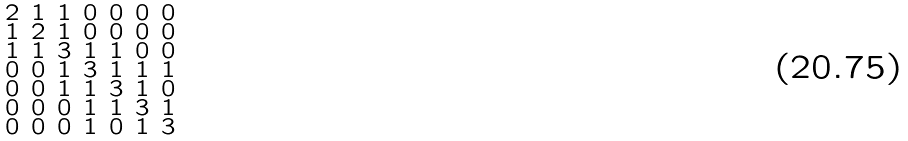Convert formula to latex. <formula><loc_0><loc_0><loc_500><loc_500>\begin{smallmatrix} 2 & 1 & 1 & 0 & 0 & 0 & 0 \\ 1 & 2 & 1 & 0 & 0 & 0 & 0 \\ 1 & 1 & 3 & 1 & 1 & 0 & 0 \\ 0 & 0 & 1 & 3 & 1 & 1 & 1 \\ 0 & 0 & 1 & 1 & 3 & 1 & 0 \\ 0 & 0 & 0 & 1 & 1 & 3 & 1 \\ 0 & 0 & 0 & 1 & 0 & 1 & 3 \end{smallmatrix}</formula> 